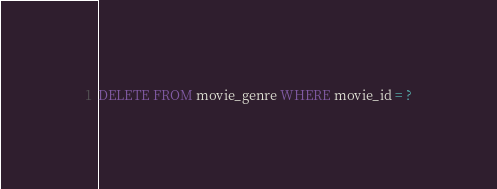Convert code to text. <code><loc_0><loc_0><loc_500><loc_500><_SQL_>DELETE FROM movie_genre WHERE movie_id = ?</code> 